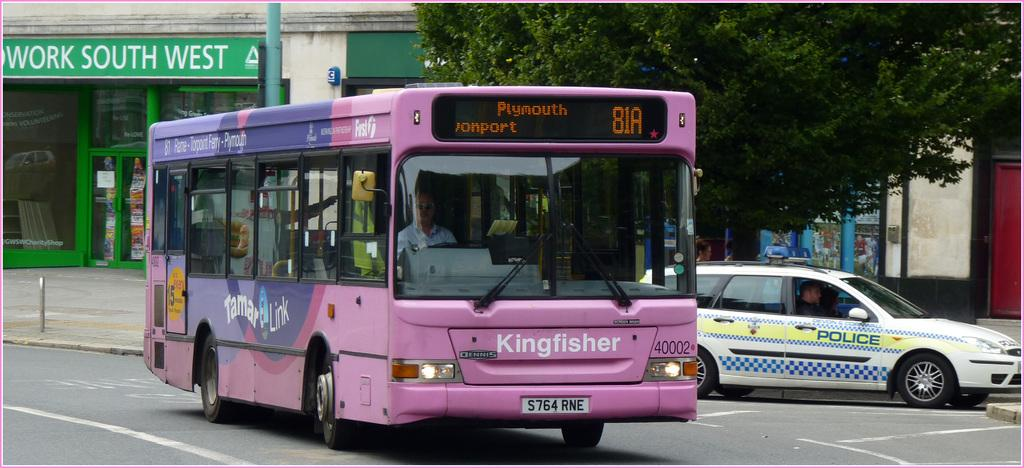<image>
Relay a brief, clear account of the picture shown. A purple bus says Plymouth and is crossing an intersection. 